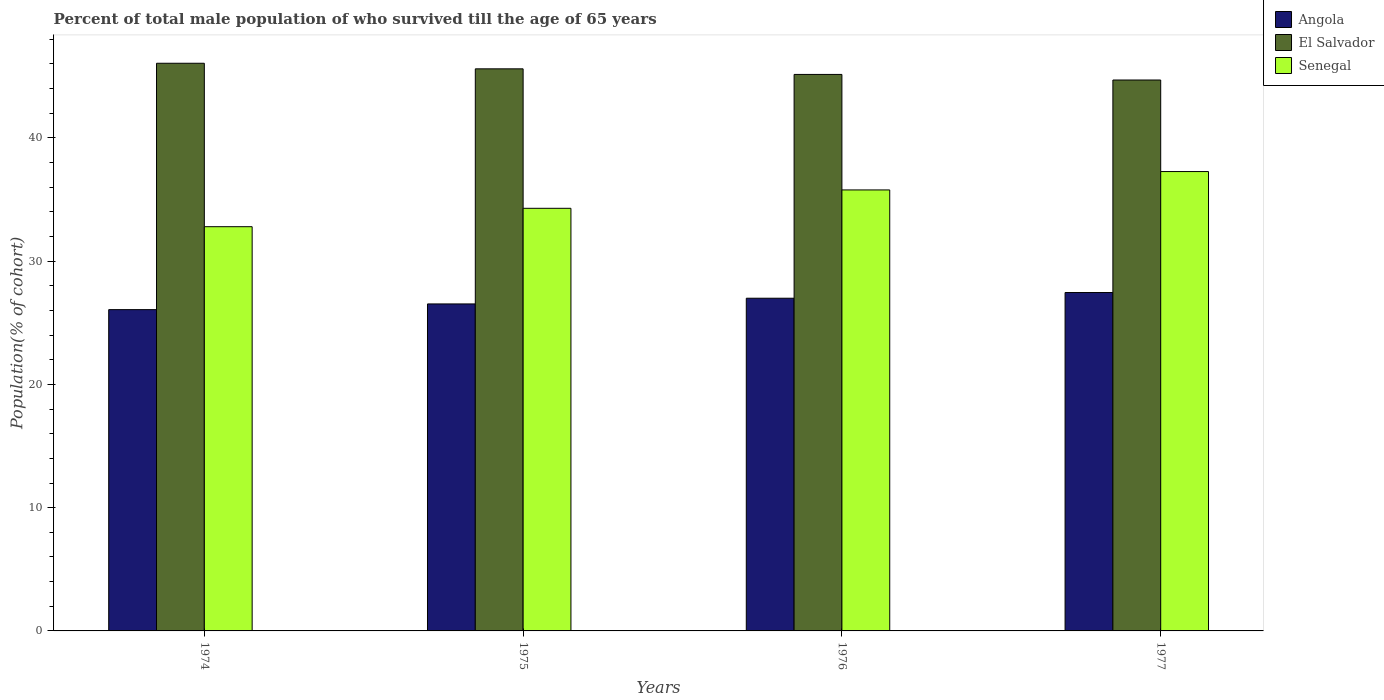How many different coloured bars are there?
Offer a very short reply. 3. How many groups of bars are there?
Your response must be concise. 4. Are the number of bars per tick equal to the number of legend labels?
Your answer should be very brief. Yes. How many bars are there on the 1st tick from the right?
Ensure brevity in your answer.  3. What is the label of the 2nd group of bars from the left?
Provide a succinct answer. 1975. In how many cases, is the number of bars for a given year not equal to the number of legend labels?
Ensure brevity in your answer.  0. What is the percentage of total male population who survived till the age of 65 years in Angola in 1974?
Give a very brief answer. 26.06. Across all years, what is the maximum percentage of total male population who survived till the age of 65 years in Senegal?
Make the answer very short. 37.27. Across all years, what is the minimum percentage of total male population who survived till the age of 65 years in Angola?
Your answer should be very brief. 26.06. In which year was the percentage of total male population who survived till the age of 65 years in Angola maximum?
Provide a succinct answer. 1977. In which year was the percentage of total male population who survived till the age of 65 years in Angola minimum?
Offer a very short reply. 1974. What is the total percentage of total male population who survived till the age of 65 years in Senegal in the graph?
Your response must be concise. 140.12. What is the difference between the percentage of total male population who survived till the age of 65 years in Senegal in 1974 and that in 1975?
Your answer should be very brief. -1.49. What is the difference between the percentage of total male population who survived till the age of 65 years in Angola in 1977 and the percentage of total male population who survived till the age of 65 years in Senegal in 1975?
Offer a terse response. -6.83. What is the average percentage of total male population who survived till the age of 65 years in El Salvador per year?
Offer a very short reply. 45.37. In the year 1977, what is the difference between the percentage of total male population who survived till the age of 65 years in El Salvador and percentage of total male population who survived till the age of 65 years in Angola?
Provide a short and direct response. 17.24. In how many years, is the percentage of total male population who survived till the age of 65 years in El Salvador greater than 32 %?
Your answer should be compact. 4. What is the ratio of the percentage of total male population who survived till the age of 65 years in El Salvador in 1974 to that in 1977?
Your response must be concise. 1.03. Is the percentage of total male population who survived till the age of 65 years in El Salvador in 1974 less than that in 1975?
Ensure brevity in your answer.  No. Is the difference between the percentage of total male population who survived till the age of 65 years in El Salvador in 1975 and 1976 greater than the difference between the percentage of total male population who survived till the age of 65 years in Angola in 1975 and 1976?
Your answer should be very brief. Yes. What is the difference between the highest and the second highest percentage of total male population who survived till the age of 65 years in Angola?
Offer a very short reply. 0.46. What is the difference between the highest and the lowest percentage of total male population who survived till the age of 65 years in Senegal?
Give a very brief answer. 4.47. In how many years, is the percentage of total male population who survived till the age of 65 years in El Salvador greater than the average percentage of total male population who survived till the age of 65 years in El Salvador taken over all years?
Offer a terse response. 2. What does the 2nd bar from the left in 1976 represents?
Give a very brief answer. El Salvador. What does the 3rd bar from the right in 1977 represents?
Offer a very short reply. Angola. Is it the case that in every year, the sum of the percentage of total male population who survived till the age of 65 years in Angola and percentage of total male population who survived till the age of 65 years in El Salvador is greater than the percentage of total male population who survived till the age of 65 years in Senegal?
Keep it short and to the point. Yes. How many bars are there?
Give a very brief answer. 12. How many years are there in the graph?
Your answer should be compact. 4. What is the difference between two consecutive major ticks on the Y-axis?
Offer a terse response. 10. Where does the legend appear in the graph?
Your answer should be compact. Top right. How many legend labels are there?
Your answer should be compact. 3. What is the title of the graph?
Provide a succinct answer. Percent of total male population of who survived till the age of 65 years. Does "Nepal" appear as one of the legend labels in the graph?
Provide a short and direct response. No. What is the label or title of the X-axis?
Offer a very short reply. Years. What is the label or title of the Y-axis?
Make the answer very short. Population(% of cohort). What is the Population(% of cohort) in Angola in 1974?
Provide a short and direct response. 26.06. What is the Population(% of cohort) in El Salvador in 1974?
Ensure brevity in your answer.  46.05. What is the Population(% of cohort) of Senegal in 1974?
Make the answer very short. 32.79. What is the Population(% of cohort) in Angola in 1975?
Ensure brevity in your answer.  26.53. What is the Population(% of cohort) in El Salvador in 1975?
Your answer should be compact. 45.6. What is the Population(% of cohort) in Senegal in 1975?
Your response must be concise. 34.28. What is the Population(% of cohort) in Angola in 1976?
Keep it short and to the point. 26.99. What is the Population(% of cohort) of El Salvador in 1976?
Give a very brief answer. 45.15. What is the Population(% of cohort) in Senegal in 1976?
Provide a short and direct response. 35.78. What is the Population(% of cohort) in Angola in 1977?
Offer a terse response. 27.45. What is the Population(% of cohort) in El Salvador in 1977?
Your answer should be very brief. 44.69. What is the Population(% of cohort) in Senegal in 1977?
Your answer should be compact. 37.27. Across all years, what is the maximum Population(% of cohort) of Angola?
Provide a succinct answer. 27.45. Across all years, what is the maximum Population(% of cohort) in El Salvador?
Offer a very short reply. 46.05. Across all years, what is the maximum Population(% of cohort) in Senegal?
Offer a terse response. 37.27. Across all years, what is the minimum Population(% of cohort) in Angola?
Provide a succinct answer. 26.06. Across all years, what is the minimum Population(% of cohort) of El Salvador?
Provide a succinct answer. 44.69. Across all years, what is the minimum Population(% of cohort) of Senegal?
Your answer should be compact. 32.79. What is the total Population(% of cohort) in Angola in the graph?
Make the answer very short. 107.04. What is the total Population(% of cohort) of El Salvador in the graph?
Keep it short and to the point. 181.49. What is the total Population(% of cohort) in Senegal in the graph?
Your answer should be compact. 140.12. What is the difference between the Population(% of cohort) of Angola in 1974 and that in 1975?
Give a very brief answer. -0.46. What is the difference between the Population(% of cohort) of El Salvador in 1974 and that in 1975?
Give a very brief answer. 0.45. What is the difference between the Population(% of cohort) in Senegal in 1974 and that in 1975?
Offer a terse response. -1.49. What is the difference between the Population(% of cohort) in Angola in 1974 and that in 1976?
Your answer should be compact. -0.93. What is the difference between the Population(% of cohort) of El Salvador in 1974 and that in 1976?
Keep it short and to the point. 0.91. What is the difference between the Population(% of cohort) in Senegal in 1974 and that in 1976?
Give a very brief answer. -2.98. What is the difference between the Population(% of cohort) in Angola in 1974 and that in 1977?
Give a very brief answer. -1.39. What is the difference between the Population(% of cohort) of El Salvador in 1974 and that in 1977?
Make the answer very short. 1.36. What is the difference between the Population(% of cohort) in Senegal in 1974 and that in 1977?
Your response must be concise. -4.47. What is the difference between the Population(% of cohort) in Angola in 1975 and that in 1976?
Provide a short and direct response. -0.46. What is the difference between the Population(% of cohort) of El Salvador in 1975 and that in 1976?
Provide a succinct answer. 0.45. What is the difference between the Population(% of cohort) of Senegal in 1975 and that in 1976?
Offer a very short reply. -1.49. What is the difference between the Population(% of cohort) in Angola in 1975 and that in 1977?
Provide a short and direct response. -0.93. What is the difference between the Population(% of cohort) of El Salvador in 1975 and that in 1977?
Ensure brevity in your answer.  0.91. What is the difference between the Population(% of cohort) in Senegal in 1975 and that in 1977?
Provide a short and direct response. -2.98. What is the difference between the Population(% of cohort) of Angola in 1976 and that in 1977?
Offer a terse response. -0.46. What is the difference between the Population(% of cohort) of El Salvador in 1976 and that in 1977?
Provide a succinct answer. 0.45. What is the difference between the Population(% of cohort) of Senegal in 1976 and that in 1977?
Offer a very short reply. -1.49. What is the difference between the Population(% of cohort) of Angola in 1974 and the Population(% of cohort) of El Salvador in 1975?
Your answer should be very brief. -19.53. What is the difference between the Population(% of cohort) in Angola in 1974 and the Population(% of cohort) in Senegal in 1975?
Provide a succinct answer. -8.22. What is the difference between the Population(% of cohort) in El Salvador in 1974 and the Population(% of cohort) in Senegal in 1975?
Keep it short and to the point. 11.77. What is the difference between the Population(% of cohort) of Angola in 1974 and the Population(% of cohort) of El Salvador in 1976?
Your answer should be very brief. -19.08. What is the difference between the Population(% of cohort) of Angola in 1974 and the Population(% of cohort) of Senegal in 1976?
Your response must be concise. -9.71. What is the difference between the Population(% of cohort) in El Salvador in 1974 and the Population(% of cohort) in Senegal in 1976?
Make the answer very short. 10.28. What is the difference between the Population(% of cohort) in Angola in 1974 and the Population(% of cohort) in El Salvador in 1977?
Your answer should be very brief. -18.63. What is the difference between the Population(% of cohort) of Angola in 1974 and the Population(% of cohort) of Senegal in 1977?
Your answer should be compact. -11.2. What is the difference between the Population(% of cohort) of El Salvador in 1974 and the Population(% of cohort) of Senegal in 1977?
Ensure brevity in your answer.  8.79. What is the difference between the Population(% of cohort) in Angola in 1975 and the Population(% of cohort) in El Salvador in 1976?
Provide a short and direct response. -18.62. What is the difference between the Population(% of cohort) in Angola in 1975 and the Population(% of cohort) in Senegal in 1976?
Make the answer very short. -9.25. What is the difference between the Population(% of cohort) in El Salvador in 1975 and the Population(% of cohort) in Senegal in 1976?
Give a very brief answer. 9.82. What is the difference between the Population(% of cohort) in Angola in 1975 and the Population(% of cohort) in El Salvador in 1977?
Your answer should be compact. -18.17. What is the difference between the Population(% of cohort) in Angola in 1975 and the Population(% of cohort) in Senegal in 1977?
Your answer should be compact. -10.74. What is the difference between the Population(% of cohort) of El Salvador in 1975 and the Population(% of cohort) of Senegal in 1977?
Offer a very short reply. 8.33. What is the difference between the Population(% of cohort) of Angola in 1976 and the Population(% of cohort) of El Salvador in 1977?
Offer a terse response. -17.7. What is the difference between the Population(% of cohort) in Angola in 1976 and the Population(% of cohort) in Senegal in 1977?
Offer a very short reply. -10.28. What is the difference between the Population(% of cohort) in El Salvador in 1976 and the Population(% of cohort) in Senegal in 1977?
Offer a terse response. 7.88. What is the average Population(% of cohort) of Angola per year?
Your answer should be very brief. 26.76. What is the average Population(% of cohort) in El Salvador per year?
Provide a succinct answer. 45.37. What is the average Population(% of cohort) of Senegal per year?
Offer a very short reply. 35.03. In the year 1974, what is the difference between the Population(% of cohort) of Angola and Population(% of cohort) of El Salvador?
Ensure brevity in your answer.  -19.99. In the year 1974, what is the difference between the Population(% of cohort) in Angola and Population(% of cohort) in Senegal?
Offer a very short reply. -6.73. In the year 1974, what is the difference between the Population(% of cohort) of El Salvador and Population(% of cohort) of Senegal?
Provide a short and direct response. 13.26. In the year 1975, what is the difference between the Population(% of cohort) in Angola and Population(% of cohort) in El Salvador?
Your answer should be very brief. -19.07. In the year 1975, what is the difference between the Population(% of cohort) of Angola and Population(% of cohort) of Senegal?
Provide a short and direct response. -7.76. In the year 1975, what is the difference between the Population(% of cohort) of El Salvador and Population(% of cohort) of Senegal?
Make the answer very short. 11.31. In the year 1976, what is the difference between the Population(% of cohort) of Angola and Population(% of cohort) of El Salvador?
Your answer should be very brief. -18.16. In the year 1976, what is the difference between the Population(% of cohort) of Angola and Population(% of cohort) of Senegal?
Ensure brevity in your answer.  -8.79. In the year 1976, what is the difference between the Population(% of cohort) in El Salvador and Population(% of cohort) in Senegal?
Provide a short and direct response. 9.37. In the year 1977, what is the difference between the Population(% of cohort) in Angola and Population(% of cohort) in El Salvador?
Provide a succinct answer. -17.24. In the year 1977, what is the difference between the Population(% of cohort) in Angola and Population(% of cohort) in Senegal?
Your response must be concise. -9.81. In the year 1977, what is the difference between the Population(% of cohort) of El Salvador and Population(% of cohort) of Senegal?
Ensure brevity in your answer.  7.43. What is the ratio of the Population(% of cohort) of Angola in 1974 to that in 1975?
Make the answer very short. 0.98. What is the ratio of the Population(% of cohort) in El Salvador in 1974 to that in 1975?
Your answer should be compact. 1.01. What is the ratio of the Population(% of cohort) in Senegal in 1974 to that in 1975?
Make the answer very short. 0.96. What is the ratio of the Population(% of cohort) in Angola in 1974 to that in 1976?
Your answer should be very brief. 0.97. What is the ratio of the Population(% of cohort) in El Salvador in 1974 to that in 1976?
Your answer should be very brief. 1.02. What is the ratio of the Population(% of cohort) in Senegal in 1974 to that in 1976?
Give a very brief answer. 0.92. What is the ratio of the Population(% of cohort) in Angola in 1974 to that in 1977?
Keep it short and to the point. 0.95. What is the ratio of the Population(% of cohort) in El Salvador in 1974 to that in 1977?
Provide a succinct answer. 1.03. What is the ratio of the Population(% of cohort) in Senegal in 1974 to that in 1977?
Your answer should be compact. 0.88. What is the ratio of the Population(% of cohort) of Angola in 1975 to that in 1976?
Your answer should be compact. 0.98. What is the ratio of the Population(% of cohort) of Angola in 1975 to that in 1977?
Offer a terse response. 0.97. What is the ratio of the Population(% of cohort) of El Salvador in 1975 to that in 1977?
Provide a short and direct response. 1.02. What is the ratio of the Population(% of cohort) of Angola in 1976 to that in 1977?
Give a very brief answer. 0.98. What is the ratio of the Population(% of cohort) of El Salvador in 1976 to that in 1977?
Your answer should be compact. 1.01. What is the difference between the highest and the second highest Population(% of cohort) of Angola?
Your response must be concise. 0.46. What is the difference between the highest and the second highest Population(% of cohort) of El Salvador?
Give a very brief answer. 0.45. What is the difference between the highest and the second highest Population(% of cohort) of Senegal?
Make the answer very short. 1.49. What is the difference between the highest and the lowest Population(% of cohort) in Angola?
Ensure brevity in your answer.  1.39. What is the difference between the highest and the lowest Population(% of cohort) of El Salvador?
Keep it short and to the point. 1.36. What is the difference between the highest and the lowest Population(% of cohort) in Senegal?
Offer a terse response. 4.47. 